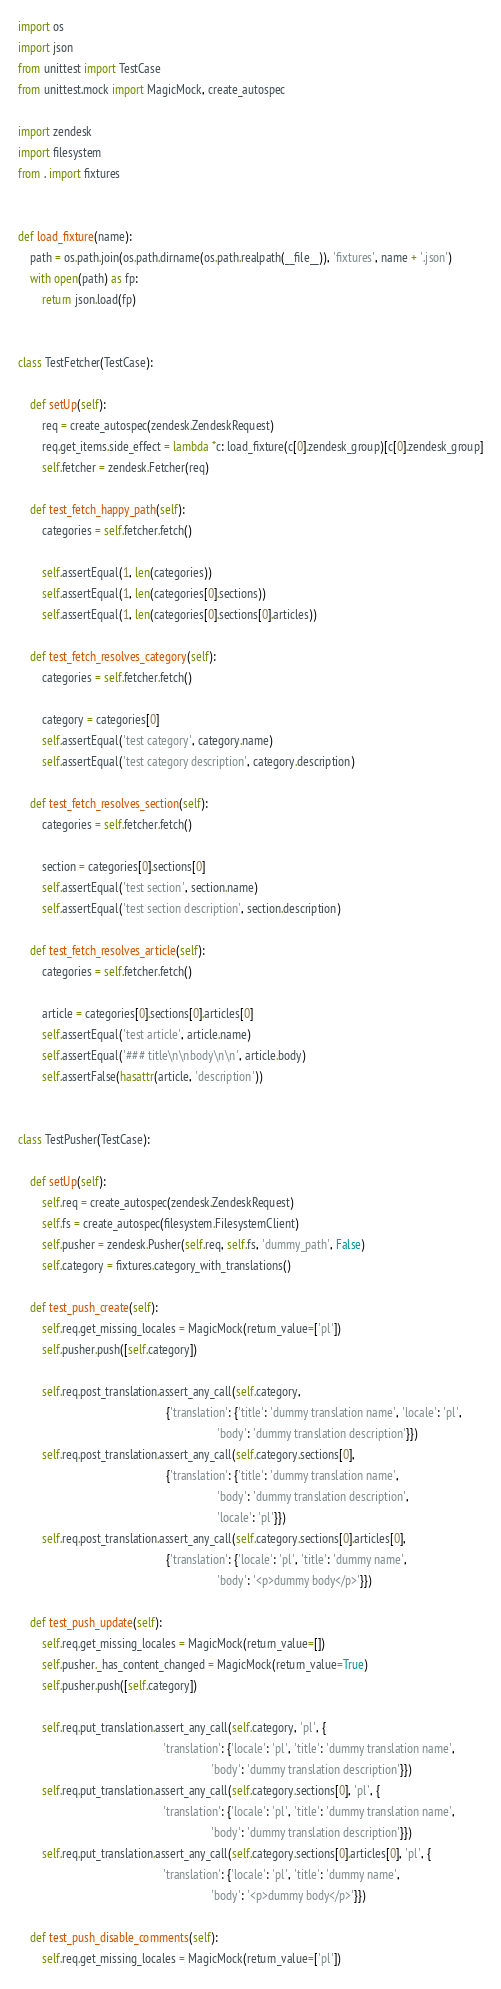Convert code to text. <code><loc_0><loc_0><loc_500><loc_500><_Python_>import os
import json
from unittest import TestCase
from unittest.mock import MagicMock, create_autospec

import zendesk
import filesystem
from . import fixtures


def load_fixture(name):
    path = os.path.join(os.path.dirname(os.path.realpath(__file__)), 'fixtures', name + '.json')
    with open(path) as fp:
        return json.load(fp)


class TestFetcher(TestCase):

    def setUp(self):
        req = create_autospec(zendesk.ZendeskRequest)
        req.get_items.side_effect = lambda *c: load_fixture(c[0].zendesk_group)[c[0].zendesk_group]
        self.fetcher = zendesk.Fetcher(req)

    def test_fetch_happy_path(self):
        categories = self.fetcher.fetch()

        self.assertEqual(1, len(categories))
        self.assertEqual(1, len(categories[0].sections))
        self.assertEqual(1, len(categories[0].sections[0].articles))

    def test_fetch_resolves_category(self):
        categories = self.fetcher.fetch()

        category = categories[0]
        self.assertEqual('test category', category.name)
        self.assertEqual('test category description', category.description)

    def test_fetch_resolves_section(self):
        categories = self.fetcher.fetch()

        section = categories[0].sections[0]
        self.assertEqual('test section', section.name)
        self.assertEqual('test section description', section.description)

    def test_fetch_resolves_article(self):
        categories = self.fetcher.fetch()

        article = categories[0].sections[0].articles[0]
        self.assertEqual('test article', article.name)
        self.assertEqual('### title\n\nbody\n\n', article.body)
        self.assertFalse(hasattr(article, 'description'))


class TestPusher(TestCase):

    def setUp(self):
        self.req = create_autospec(zendesk.ZendeskRequest)
        self.fs = create_autospec(filesystem.FilesystemClient)
        self.pusher = zendesk.Pusher(self.req, self.fs, 'dummy_path', False)
        self.category = fixtures.category_with_translations()

    def test_push_create(self):
        self.req.get_missing_locales = MagicMock(return_value=['pl'])
        self.pusher.push([self.category])

        self.req.post_translation.assert_any_call(self.category,
                                                  {'translation': {'title': 'dummy translation name', 'locale': 'pl',
                                                                   'body': 'dummy translation description'}})
        self.req.post_translation.assert_any_call(self.category.sections[0],
                                                  {'translation': {'title': 'dummy translation name',
                                                                   'body': 'dummy translation description',
                                                                   'locale': 'pl'}})
        self.req.post_translation.assert_any_call(self.category.sections[0].articles[0],
                                                  {'translation': {'locale': 'pl', 'title': 'dummy name',
                                                                   'body': '<p>dummy body</p>'}})

    def test_push_update(self):
        self.req.get_missing_locales = MagicMock(return_value=[])
        self.pusher._has_content_changed = MagicMock(return_value=True)
        self.pusher.push([self.category])

        self.req.put_translation.assert_any_call(self.category, 'pl', {
                                                 'translation': {'locale': 'pl', 'title': 'dummy translation name',
                                                                 'body': 'dummy translation description'}})
        self.req.put_translation.assert_any_call(self.category.sections[0], 'pl', {
                                                 'translation': {'locale': 'pl', 'title': 'dummy translation name',
                                                                 'body': 'dummy translation description'}})
        self.req.put_translation.assert_any_call(self.category.sections[0].articles[0], 'pl', {
                                                 'translation': {'locale': 'pl', 'title': 'dummy name',
                                                                 'body': '<p>dummy body</p>'}})

    def test_push_disable_comments(self):
        self.req.get_missing_locales = MagicMock(return_value=['pl'])</code> 